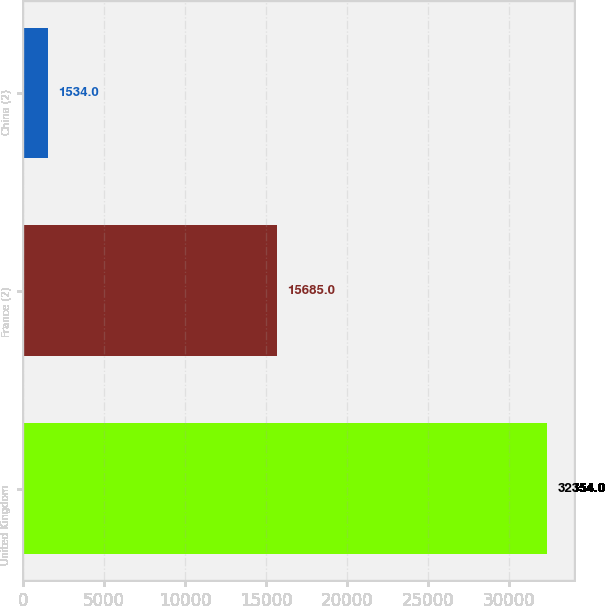Convert chart. <chart><loc_0><loc_0><loc_500><loc_500><bar_chart><fcel>United Kingdom<fcel>France (2)<fcel>China (2)<nl><fcel>32354<fcel>15685<fcel>1534<nl></chart> 